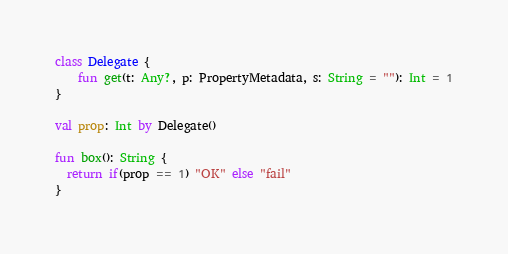<code> <loc_0><loc_0><loc_500><loc_500><_Kotlin_>class Delegate {
    fun get(t: Any?, p: PropertyMetadata, s: String = ""): Int = 1
}

val prop: Int by Delegate()

fun box(): String {
  return if(prop == 1) "OK" else "fail"
}
</code> 